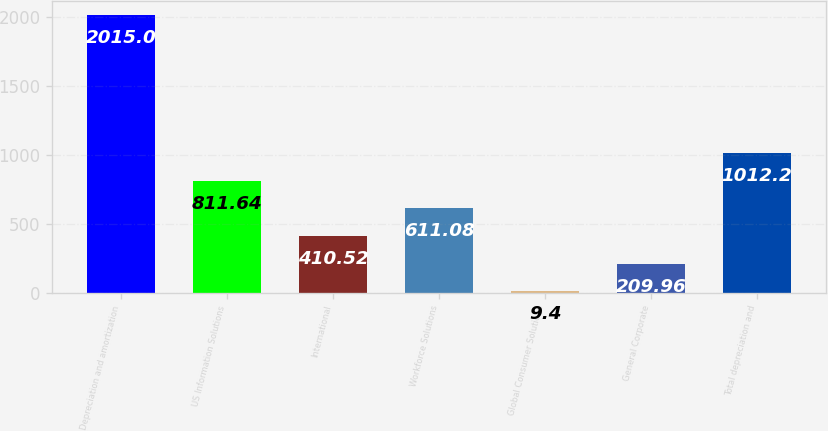Convert chart. <chart><loc_0><loc_0><loc_500><loc_500><bar_chart><fcel>Depreciation and amortization<fcel>US Information Solutions<fcel>International<fcel>Workforce Solutions<fcel>Global Consumer Solutions<fcel>General Corporate<fcel>Total depreciation and<nl><fcel>2015<fcel>811.64<fcel>410.52<fcel>611.08<fcel>9.4<fcel>209.96<fcel>1012.2<nl></chart> 